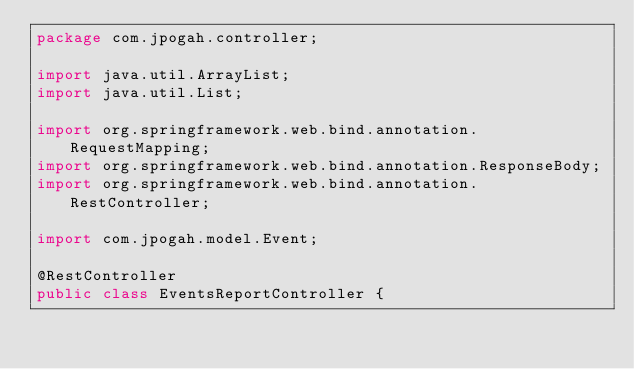<code> <loc_0><loc_0><loc_500><loc_500><_Java_>package com.jpogah.controller;

import java.util.ArrayList;
import java.util.List;

import org.springframework.web.bind.annotation.RequestMapping;
import org.springframework.web.bind.annotation.ResponseBody;
import org.springframework.web.bind.annotation.RestController;

import com.jpogah.model.Event;

@RestController
public class EventsReportController {
	</code> 